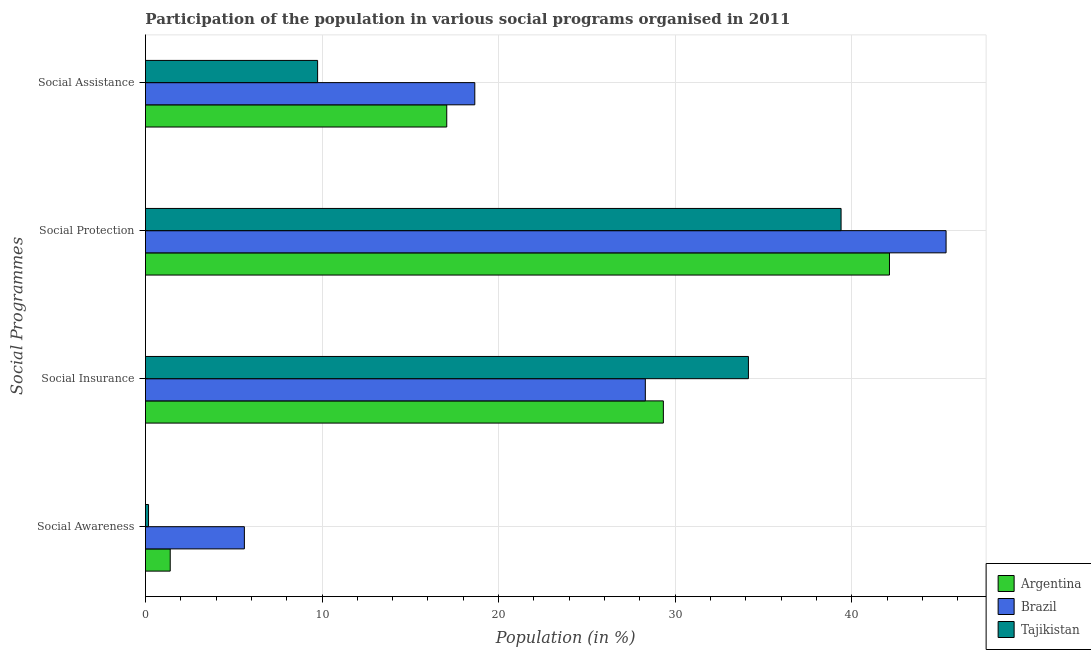How many different coloured bars are there?
Your response must be concise. 3. Are the number of bars per tick equal to the number of legend labels?
Provide a short and direct response. Yes. What is the label of the 4th group of bars from the top?
Your answer should be very brief. Social Awareness. What is the participation of population in social assistance programs in Tajikistan?
Your answer should be very brief. 9.75. Across all countries, what is the maximum participation of population in social assistance programs?
Keep it short and to the point. 18.65. Across all countries, what is the minimum participation of population in social assistance programs?
Give a very brief answer. 9.75. In which country was the participation of population in social awareness programs maximum?
Provide a succinct answer. Brazil. In which country was the participation of population in social protection programs minimum?
Ensure brevity in your answer.  Tajikistan. What is the total participation of population in social awareness programs in the graph?
Offer a terse response. 7.18. What is the difference between the participation of population in social protection programs in Brazil and that in Tajikistan?
Provide a succinct answer. 5.95. What is the difference between the participation of population in social assistance programs in Brazil and the participation of population in social protection programs in Argentina?
Ensure brevity in your answer.  -23.49. What is the average participation of population in social assistance programs per country?
Provide a succinct answer. 15.16. What is the difference between the participation of population in social protection programs and participation of population in social awareness programs in Tajikistan?
Give a very brief answer. 39.22. In how many countries, is the participation of population in social assistance programs greater than 40 %?
Make the answer very short. 0. What is the ratio of the participation of population in social protection programs in Argentina to that in Brazil?
Provide a short and direct response. 0.93. Is the difference between the participation of population in social protection programs in Argentina and Brazil greater than the difference between the participation of population in social insurance programs in Argentina and Brazil?
Give a very brief answer. No. What is the difference between the highest and the second highest participation of population in social protection programs?
Provide a short and direct response. 3.21. What is the difference between the highest and the lowest participation of population in social insurance programs?
Offer a terse response. 5.84. Is the sum of the participation of population in social protection programs in Brazil and Tajikistan greater than the maximum participation of population in social awareness programs across all countries?
Your answer should be very brief. Yes. What does the 1st bar from the top in Social Insurance represents?
Ensure brevity in your answer.  Tajikistan. Are all the bars in the graph horizontal?
Give a very brief answer. Yes. How many countries are there in the graph?
Your answer should be very brief. 3. Does the graph contain grids?
Make the answer very short. Yes. Where does the legend appear in the graph?
Offer a very short reply. Bottom right. What is the title of the graph?
Your answer should be compact. Participation of the population in various social programs organised in 2011. What is the label or title of the Y-axis?
Offer a terse response. Social Programmes. What is the Population (in %) of Argentina in Social Awareness?
Your answer should be very brief. 1.4. What is the Population (in %) of Brazil in Social Awareness?
Keep it short and to the point. 5.6. What is the Population (in %) of Tajikistan in Social Awareness?
Offer a very short reply. 0.17. What is the Population (in %) of Argentina in Social Insurance?
Offer a very short reply. 29.33. What is the Population (in %) of Brazil in Social Insurance?
Provide a short and direct response. 28.31. What is the Population (in %) in Tajikistan in Social Insurance?
Ensure brevity in your answer.  34.15. What is the Population (in %) in Argentina in Social Protection?
Provide a short and direct response. 42.14. What is the Population (in %) in Brazil in Social Protection?
Provide a succinct answer. 45.34. What is the Population (in %) of Tajikistan in Social Protection?
Provide a short and direct response. 39.4. What is the Population (in %) in Argentina in Social Assistance?
Offer a very short reply. 17.06. What is the Population (in %) of Brazil in Social Assistance?
Keep it short and to the point. 18.65. What is the Population (in %) of Tajikistan in Social Assistance?
Provide a succinct answer. 9.75. Across all Social Programmes, what is the maximum Population (in %) in Argentina?
Give a very brief answer. 42.14. Across all Social Programmes, what is the maximum Population (in %) of Brazil?
Make the answer very short. 45.34. Across all Social Programmes, what is the maximum Population (in %) of Tajikistan?
Offer a very short reply. 39.4. Across all Social Programmes, what is the minimum Population (in %) in Argentina?
Provide a succinct answer. 1.4. Across all Social Programmes, what is the minimum Population (in %) of Brazil?
Make the answer very short. 5.6. Across all Social Programmes, what is the minimum Population (in %) of Tajikistan?
Provide a short and direct response. 0.17. What is the total Population (in %) in Argentina in the graph?
Ensure brevity in your answer.  89.94. What is the total Population (in %) in Brazil in the graph?
Provide a succinct answer. 97.91. What is the total Population (in %) in Tajikistan in the graph?
Offer a terse response. 83.47. What is the difference between the Population (in %) of Argentina in Social Awareness and that in Social Insurance?
Offer a very short reply. -27.93. What is the difference between the Population (in %) in Brazil in Social Awareness and that in Social Insurance?
Your response must be concise. -22.71. What is the difference between the Population (in %) of Tajikistan in Social Awareness and that in Social Insurance?
Your answer should be compact. -33.98. What is the difference between the Population (in %) in Argentina in Social Awareness and that in Social Protection?
Provide a succinct answer. -40.73. What is the difference between the Population (in %) of Brazil in Social Awareness and that in Social Protection?
Give a very brief answer. -39.74. What is the difference between the Population (in %) of Tajikistan in Social Awareness and that in Social Protection?
Offer a very short reply. -39.22. What is the difference between the Population (in %) in Argentina in Social Awareness and that in Social Assistance?
Keep it short and to the point. -15.66. What is the difference between the Population (in %) in Brazil in Social Awareness and that in Social Assistance?
Your response must be concise. -13.05. What is the difference between the Population (in %) in Tajikistan in Social Awareness and that in Social Assistance?
Give a very brief answer. -9.58. What is the difference between the Population (in %) of Argentina in Social Insurance and that in Social Protection?
Your response must be concise. -12.81. What is the difference between the Population (in %) in Brazil in Social Insurance and that in Social Protection?
Make the answer very short. -17.03. What is the difference between the Population (in %) of Tajikistan in Social Insurance and that in Social Protection?
Provide a succinct answer. -5.25. What is the difference between the Population (in %) of Argentina in Social Insurance and that in Social Assistance?
Your answer should be compact. 12.27. What is the difference between the Population (in %) in Brazil in Social Insurance and that in Social Assistance?
Keep it short and to the point. 9.66. What is the difference between the Population (in %) of Tajikistan in Social Insurance and that in Social Assistance?
Your answer should be compact. 24.4. What is the difference between the Population (in %) in Argentina in Social Protection and that in Social Assistance?
Offer a very short reply. 25.07. What is the difference between the Population (in %) of Brazil in Social Protection and that in Social Assistance?
Keep it short and to the point. 26.69. What is the difference between the Population (in %) of Tajikistan in Social Protection and that in Social Assistance?
Provide a succinct answer. 29.65. What is the difference between the Population (in %) in Argentina in Social Awareness and the Population (in %) in Brazil in Social Insurance?
Keep it short and to the point. -26.91. What is the difference between the Population (in %) in Argentina in Social Awareness and the Population (in %) in Tajikistan in Social Insurance?
Your answer should be very brief. -32.75. What is the difference between the Population (in %) in Brazil in Social Awareness and the Population (in %) in Tajikistan in Social Insurance?
Offer a terse response. -28.55. What is the difference between the Population (in %) of Argentina in Social Awareness and the Population (in %) of Brazil in Social Protection?
Give a very brief answer. -43.94. What is the difference between the Population (in %) in Argentina in Social Awareness and the Population (in %) in Tajikistan in Social Protection?
Make the answer very short. -37.99. What is the difference between the Population (in %) in Brazil in Social Awareness and the Population (in %) in Tajikistan in Social Protection?
Your response must be concise. -33.79. What is the difference between the Population (in %) in Argentina in Social Awareness and the Population (in %) in Brazil in Social Assistance?
Offer a very short reply. -17.25. What is the difference between the Population (in %) of Argentina in Social Awareness and the Population (in %) of Tajikistan in Social Assistance?
Your answer should be very brief. -8.35. What is the difference between the Population (in %) of Brazil in Social Awareness and the Population (in %) of Tajikistan in Social Assistance?
Keep it short and to the point. -4.15. What is the difference between the Population (in %) in Argentina in Social Insurance and the Population (in %) in Brazil in Social Protection?
Your answer should be compact. -16.01. What is the difference between the Population (in %) of Argentina in Social Insurance and the Population (in %) of Tajikistan in Social Protection?
Keep it short and to the point. -10.06. What is the difference between the Population (in %) of Brazil in Social Insurance and the Population (in %) of Tajikistan in Social Protection?
Your response must be concise. -11.09. What is the difference between the Population (in %) of Argentina in Social Insurance and the Population (in %) of Brazil in Social Assistance?
Offer a very short reply. 10.68. What is the difference between the Population (in %) in Argentina in Social Insurance and the Population (in %) in Tajikistan in Social Assistance?
Provide a short and direct response. 19.58. What is the difference between the Population (in %) of Brazil in Social Insurance and the Population (in %) of Tajikistan in Social Assistance?
Your answer should be very brief. 18.56. What is the difference between the Population (in %) of Argentina in Social Protection and the Population (in %) of Brazil in Social Assistance?
Offer a terse response. 23.49. What is the difference between the Population (in %) of Argentina in Social Protection and the Population (in %) of Tajikistan in Social Assistance?
Offer a terse response. 32.39. What is the difference between the Population (in %) in Brazil in Social Protection and the Population (in %) in Tajikistan in Social Assistance?
Offer a very short reply. 35.59. What is the average Population (in %) of Argentina per Social Programmes?
Provide a succinct answer. 22.48. What is the average Population (in %) of Brazil per Social Programmes?
Give a very brief answer. 24.48. What is the average Population (in %) of Tajikistan per Social Programmes?
Offer a very short reply. 20.87. What is the difference between the Population (in %) in Argentina and Population (in %) in Brazil in Social Awareness?
Offer a very short reply. -4.2. What is the difference between the Population (in %) of Argentina and Population (in %) of Tajikistan in Social Awareness?
Give a very brief answer. 1.23. What is the difference between the Population (in %) of Brazil and Population (in %) of Tajikistan in Social Awareness?
Your answer should be very brief. 5.43. What is the difference between the Population (in %) of Argentina and Population (in %) of Brazil in Social Insurance?
Your answer should be very brief. 1.02. What is the difference between the Population (in %) of Argentina and Population (in %) of Tajikistan in Social Insurance?
Your response must be concise. -4.82. What is the difference between the Population (in %) in Brazil and Population (in %) in Tajikistan in Social Insurance?
Provide a short and direct response. -5.84. What is the difference between the Population (in %) of Argentina and Population (in %) of Brazil in Social Protection?
Provide a short and direct response. -3.21. What is the difference between the Population (in %) of Argentina and Population (in %) of Tajikistan in Social Protection?
Offer a very short reply. 2.74. What is the difference between the Population (in %) in Brazil and Population (in %) in Tajikistan in Social Protection?
Offer a very short reply. 5.95. What is the difference between the Population (in %) in Argentina and Population (in %) in Brazil in Social Assistance?
Give a very brief answer. -1.59. What is the difference between the Population (in %) in Argentina and Population (in %) in Tajikistan in Social Assistance?
Keep it short and to the point. 7.31. What is the difference between the Population (in %) of Brazil and Population (in %) of Tajikistan in Social Assistance?
Your response must be concise. 8.9. What is the ratio of the Population (in %) of Argentina in Social Awareness to that in Social Insurance?
Offer a very short reply. 0.05. What is the ratio of the Population (in %) in Brazil in Social Awareness to that in Social Insurance?
Offer a terse response. 0.2. What is the ratio of the Population (in %) in Tajikistan in Social Awareness to that in Social Insurance?
Give a very brief answer. 0.01. What is the ratio of the Population (in %) of Argentina in Social Awareness to that in Social Protection?
Provide a short and direct response. 0.03. What is the ratio of the Population (in %) of Brazil in Social Awareness to that in Social Protection?
Provide a short and direct response. 0.12. What is the ratio of the Population (in %) of Tajikistan in Social Awareness to that in Social Protection?
Ensure brevity in your answer.  0. What is the ratio of the Population (in %) in Argentina in Social Awareness to that in Social Assistance?
Provide a succinct answer. 0.08. What is the ratio of the Population (in %) in Brazil in Social Awareness to that in Social Assistance?
Your response must be concise. 0.3. What is the ratio of the Population (in %) in Tajikistan in Social Awareness to that in Social Assistance?
Your answer should be compact. 0.02. What is the ratio of the Population (in %) of Argentina in Social Insurance to that in Social Protection?
Offer a very short reply. 0.7. What is the ratio of the Population (in %) of Brazil in Social Insurance to that in Social Protection?
Your response must be concise. 0.62. What is the ratio of the Population (in %) of Tajikistan in Social Insurance to that in Social Protection?
Make the answer very short. 0.87. What is the ratio of the Population (in %) in Argentina in Social Insurance to that in Social Assistance?
Offer a terse response. 1.72. What is the ratio of the Population (in %) of Brazil in Social Insurance to that in Social Assistance?
Make the answer very short. 1.52. What is the ratio of the Population (in %) of Tajikistan in Social Insurance to that in Social Assistance?
Provide a short and direct response. 3.5. What is the ratio of the Population (in %) of Argentina in Social Protection to that in Social Assistance?
Offer a very short reply. 2.47. What is the ratio of the Population (in %) of Brazil in Social Protection to that in Social Assistance?
Your response must be concise. 2.43. What is the ratio of the Population (in %) in Tajikistan in Social Protection to that in Social Assistance?
Your answer should be compact. 4.04. What is the difference between the highest and the second highest Population (in %) of Argentina?
Your answer should be compact. 12.81. What is the difference between the highest and the second highest Population (in %) in Brazil?
Provide a succinct answer. 17.03. What is the difference between the highest and the second highest Population (in %) in Tajikistan?
Keep it short and to the point. 5.25. What is the difference between the highest and the lowest Population (in %) of Argentina?
Provide a succinct answer. 40.73. What is the difference between the highest and the lowest Population (in %) in Brazil?
Your answer should be compact. 39.74. What is the difference between the highest and the lowest Population (in %) in Tajikistan?
Provide a short and direct response. 39.22. 